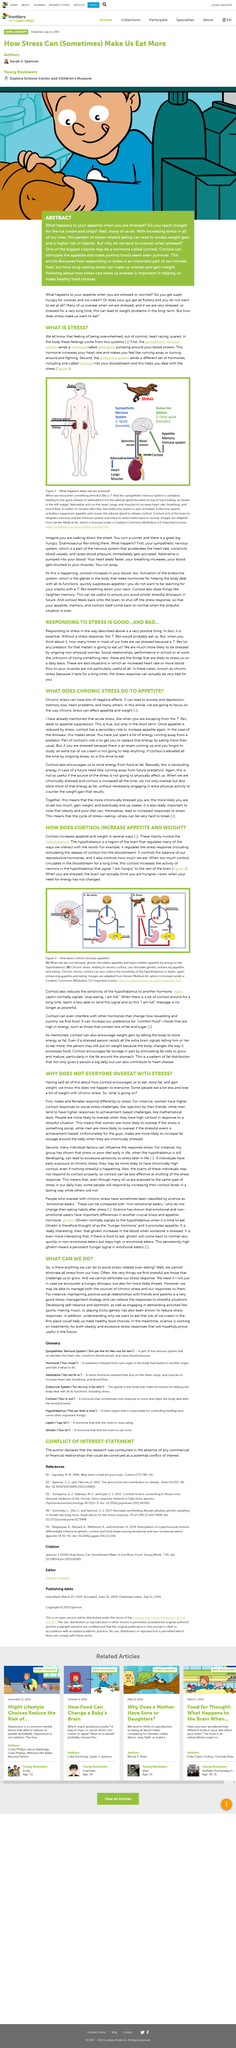Mention a couple of crucial points in this snapshot. Two systems are involved in this process. Cortisol increase leads to increased appetite and weight gain. Cortisol is a substance in our bodies that increases during times of stress. The text mentions Tyrannosaurus Rex, a dinosaur. Not all individuals engage in overeating when faced with stress, as some individuals actually consume less food in this situation. 